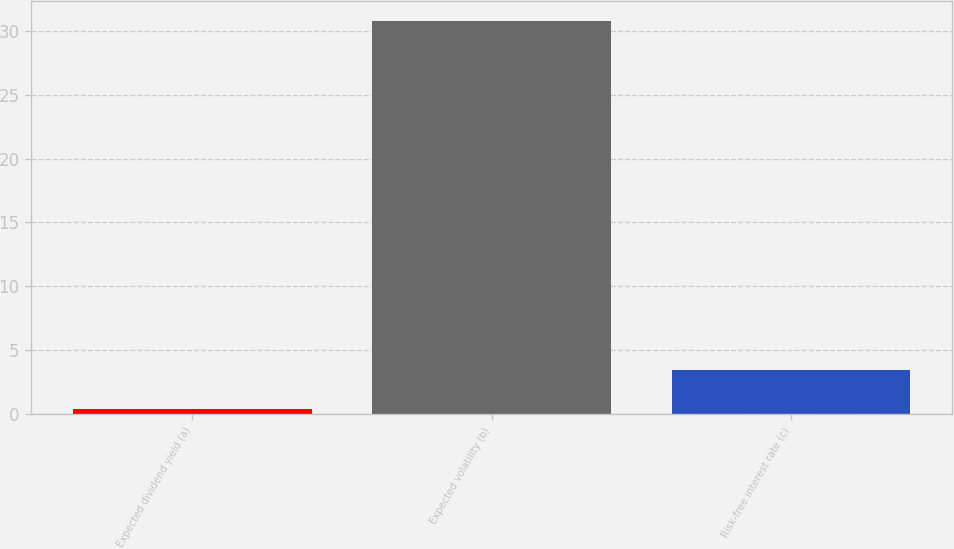<chart> <loc_0><loc_0><loc_500><loc_500><bar_chart><fcel>Expected dividend yield (a)<fcel>Expected volatility (b)<fcel>Risk-free interest rate (c)<nl><fcel>0.38<fcel>30.79<fcel>3.42<nl></chart> 